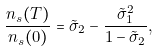Convert formula to latex. <formula><loc_0><loc_0><loc_500><loc_500>\frac { n _ { s } ( T ) } { n _ { s } ( 0 ) } = \tilde { \sigma } _ { 2 } - \frac { \tilde { \sigma } _ { 1 } ^ { 2 } } { 1 - \tilde { \sigma } _ { 2 } } ,</formula> 